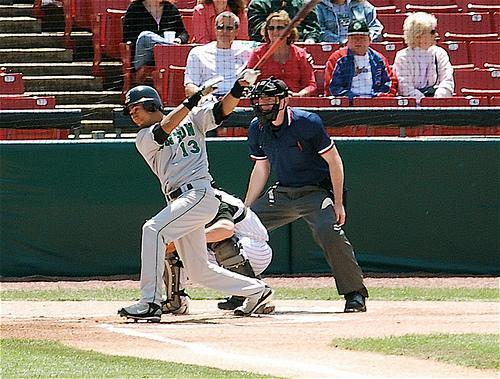How many people are visible in the stands?
Give a very brief answer. 8. How many people are there?
Give a very brief answer. 8. 